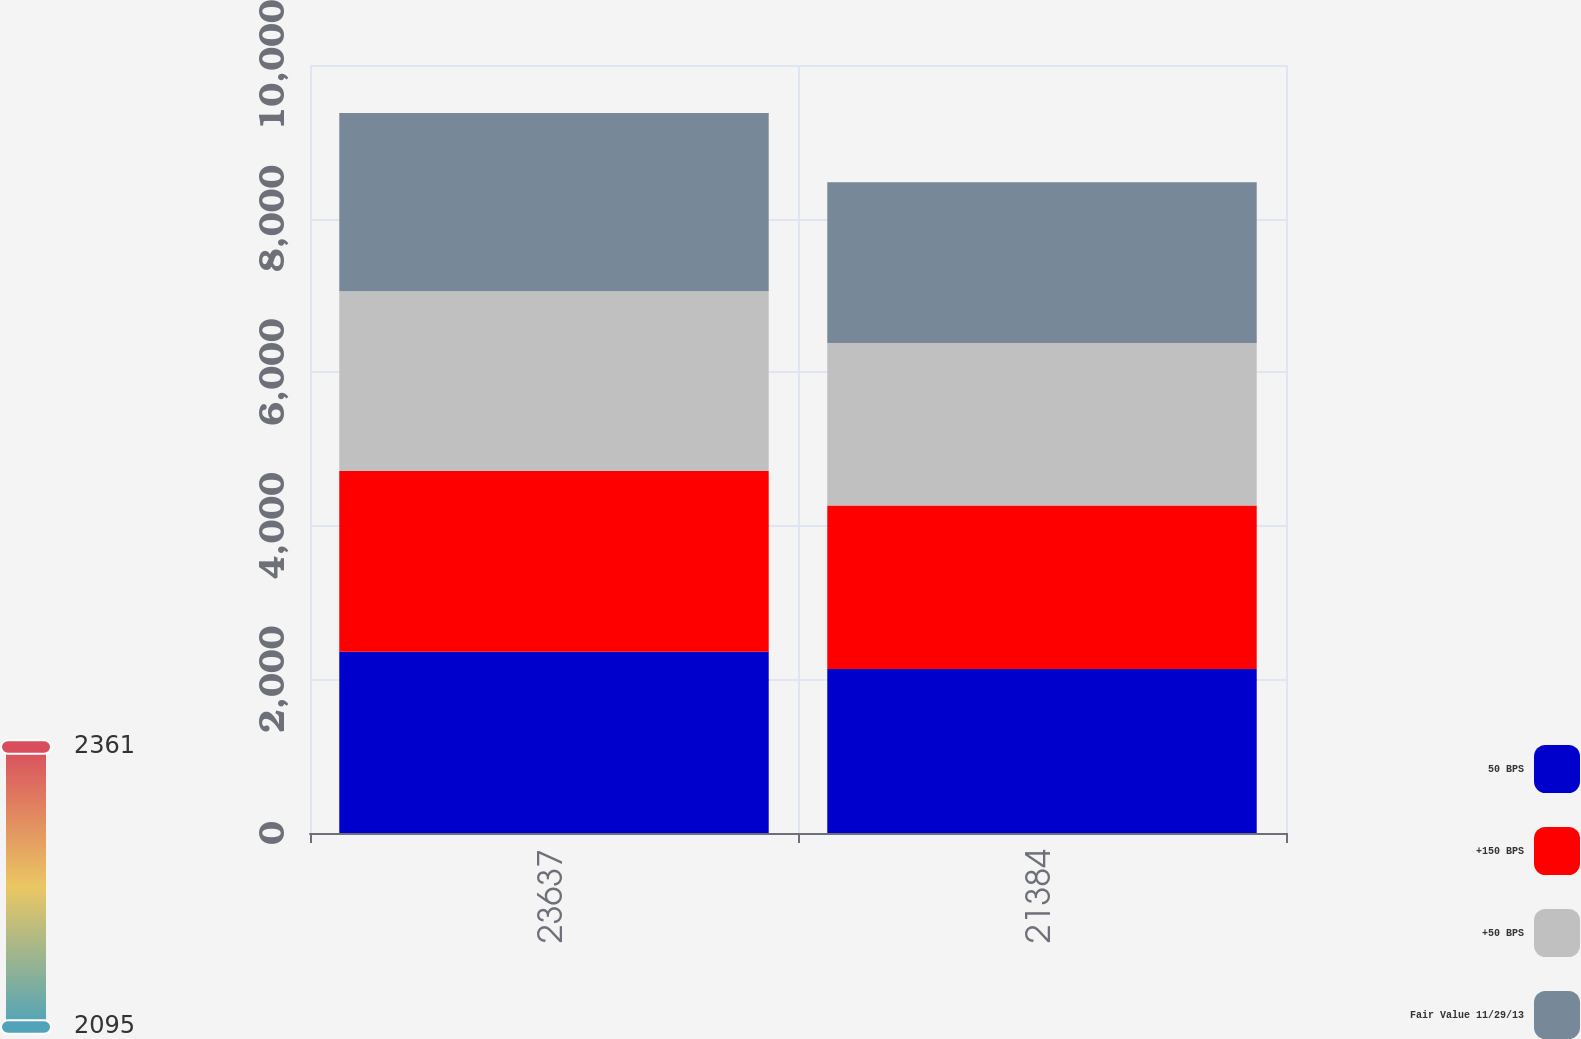Convert chart to OTSL. <chart><loc_0><loc_0><loc_500><loc_500><stacked_bar_chart><ecel><fcel>23637<fcel>21384<nl><fcel>50 BPS<fcel>2360.9<fcel>2136.6<nl><fcel>+150 BPS<fcel>2353.8<fcel>2129.3<nl><fcel>+50 BPS<fcel>2338.5<fcel>2113.1<nl><fcel>Fair Value 11/29/13<fcel>2320.5<fcel>2094.6<nl></chart> 